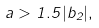<formula> <loc_0><loc_0><loc_500><loc_500>a > 1 . 5 | b _ { 2 } | ,</formula> 